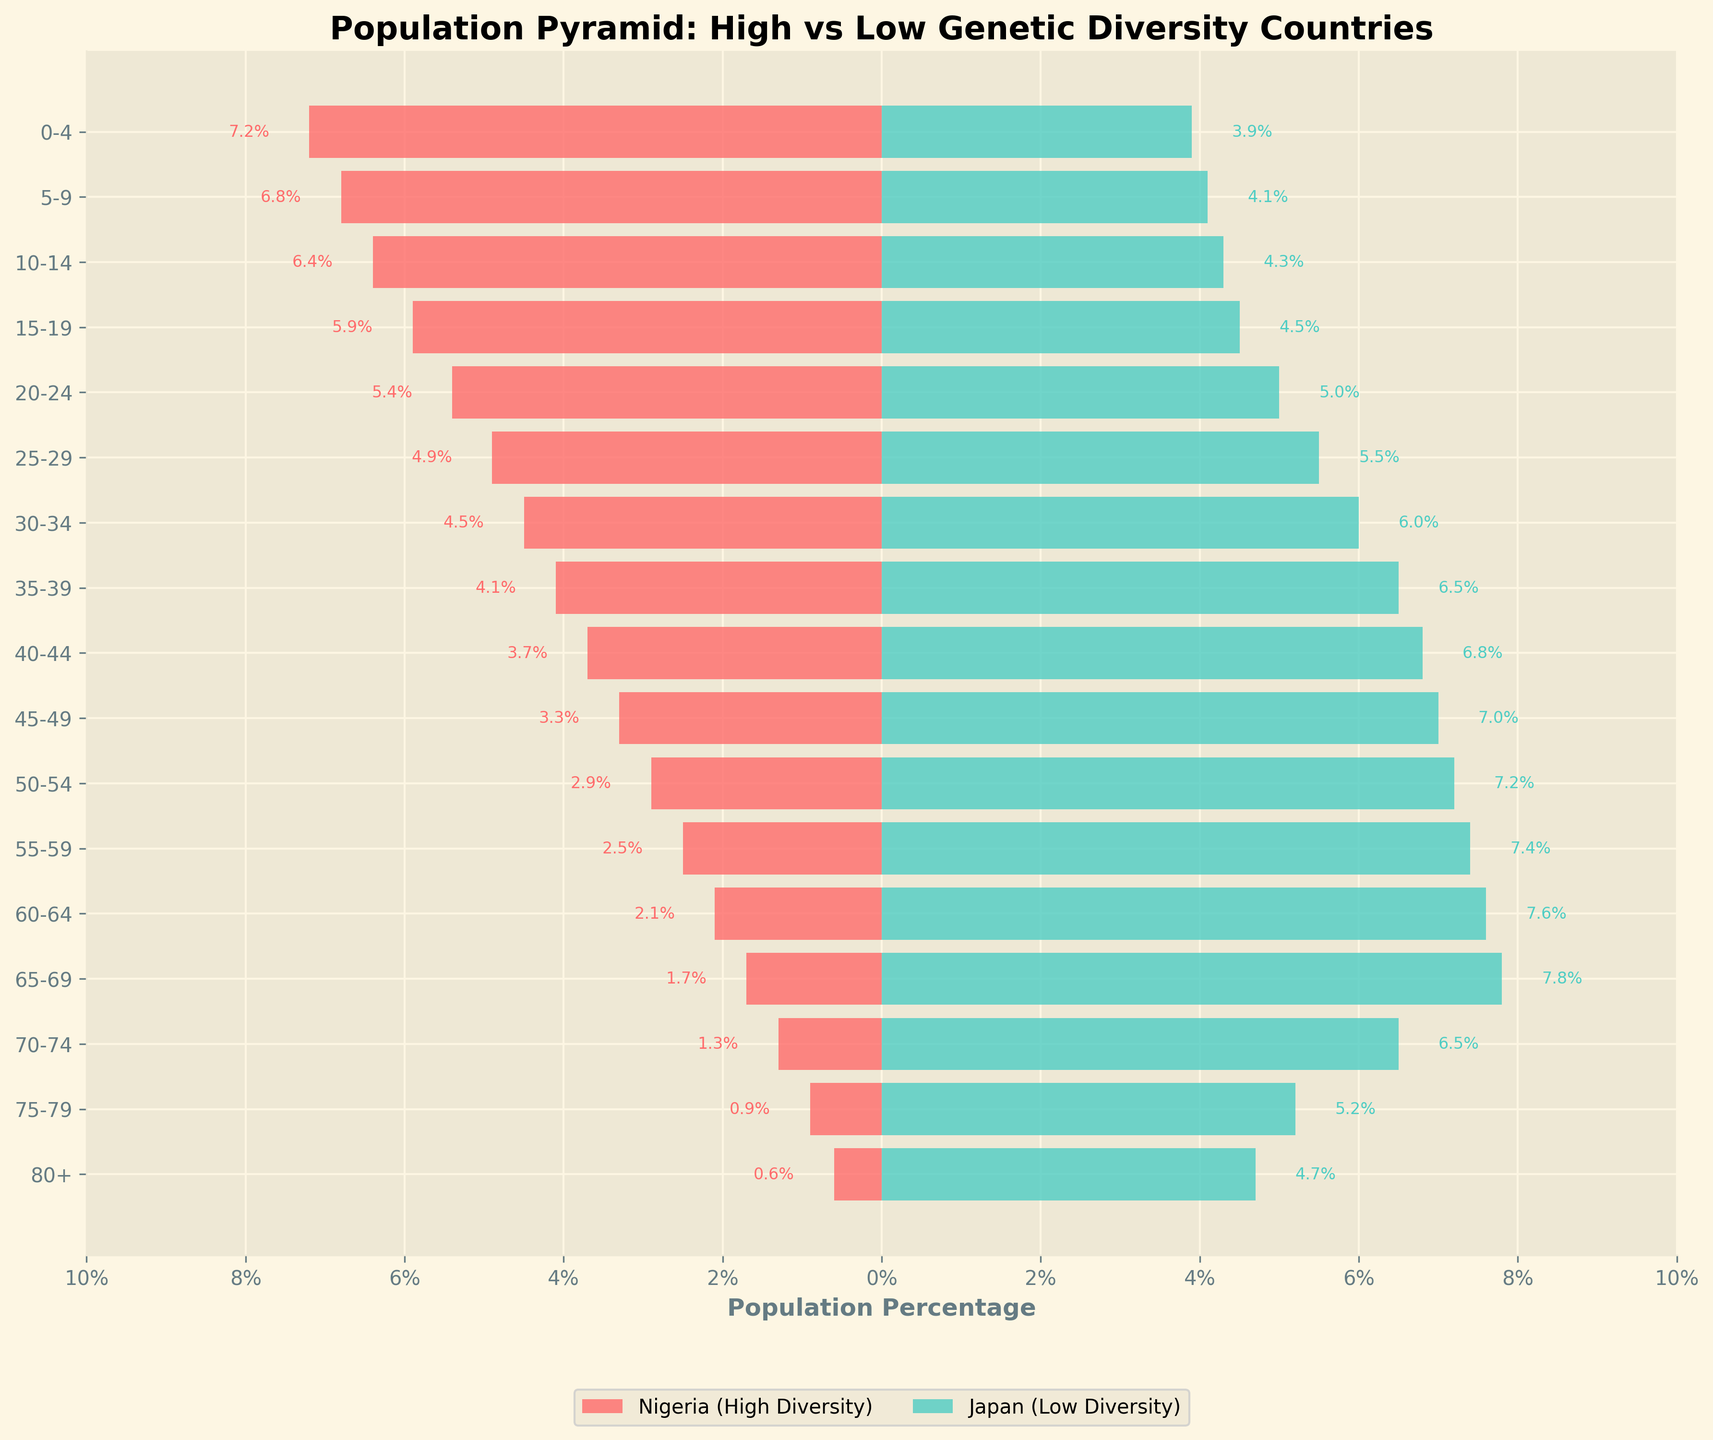What is the title of the plot? The title is typically displayed at the top of the plot. In this case, it is "Population Pyramid: High vs Low Genetic Diversity Countries".
Answer: Population Pyramid: High vs Low Genetic Diversity Countries Which age group has the highest population percentage in Nigeria (High Diversity)? To find this, look at the horizontal bars on the left side representing Nigeria. The age group with the longest bar is 0-4 years with 7.2%.
Answer: 0-4 What percentage of the population is aged 60-64 in Japan (Low Diversity)? Find the age group 60-64 on the y-axis and then check the corresponding length of the horizontal bar on the right side for Japan. The percentage is 7.6%.
Answer: 7.6% Which country has a higher percentage of its population in the 30-34 age group? Compare the length of the bars for the 30-34 age group on both sides. Japan's bar is longer than Nigeria’s, indicating a higher percentage.
Answer: Japan How does the percentage of the population aged 50-54 in Nigeria compare to Japan? Look at the 50-54 age group. Nigeria's bar is shorter at 2.9%, while Japan's bar is longer at 7.2%.
Answer: Japan has a higher percentage What is the difference in population percentage for the 25-29 age group between Nigeria and Japan? First, find the percentages for the 25-29 age group. Nigeria has 4.9% and Japan has 5.5%. Subtract Nigeria's percentage from Japan's: 5.5% - 4.9% = 0.6%.
Answer: 0.6% In which age group do both countries have the same population percentage? Identify the age group where the bars for Nigeria and Japan are the same length. In this chart, the percentages for the 80+ age group appear closest. Nigeria has 0.6% and Japan has 4.7% - no exact match. Thus, no age group has the same population percentage.
Answer: None Which country shows a higher percentage of its population in older age groups (65+)? Compare the lengths of the bars from 65+ age groups. Japan has consistently longer bars, indicating a higher percentage in these age groups.
Answer: Japan What is the total population percentage for Nigerians in the age groups 0-19? Sum the percentages for the 0-4, 5-9, 10-14, and 15-19 age groups: 7.2% + 6.8% + 6.4% + 5.9% = 26.3%.
Answer: 26.3% How much larger is the 50-54 age group in Japan compared to Nigeria? Subtract the population percentage of Nigeria’s 50-54 age group from Japan’s: 7.2% - 2.9% = 4.3% larger.
Answer: 4.3% larger 